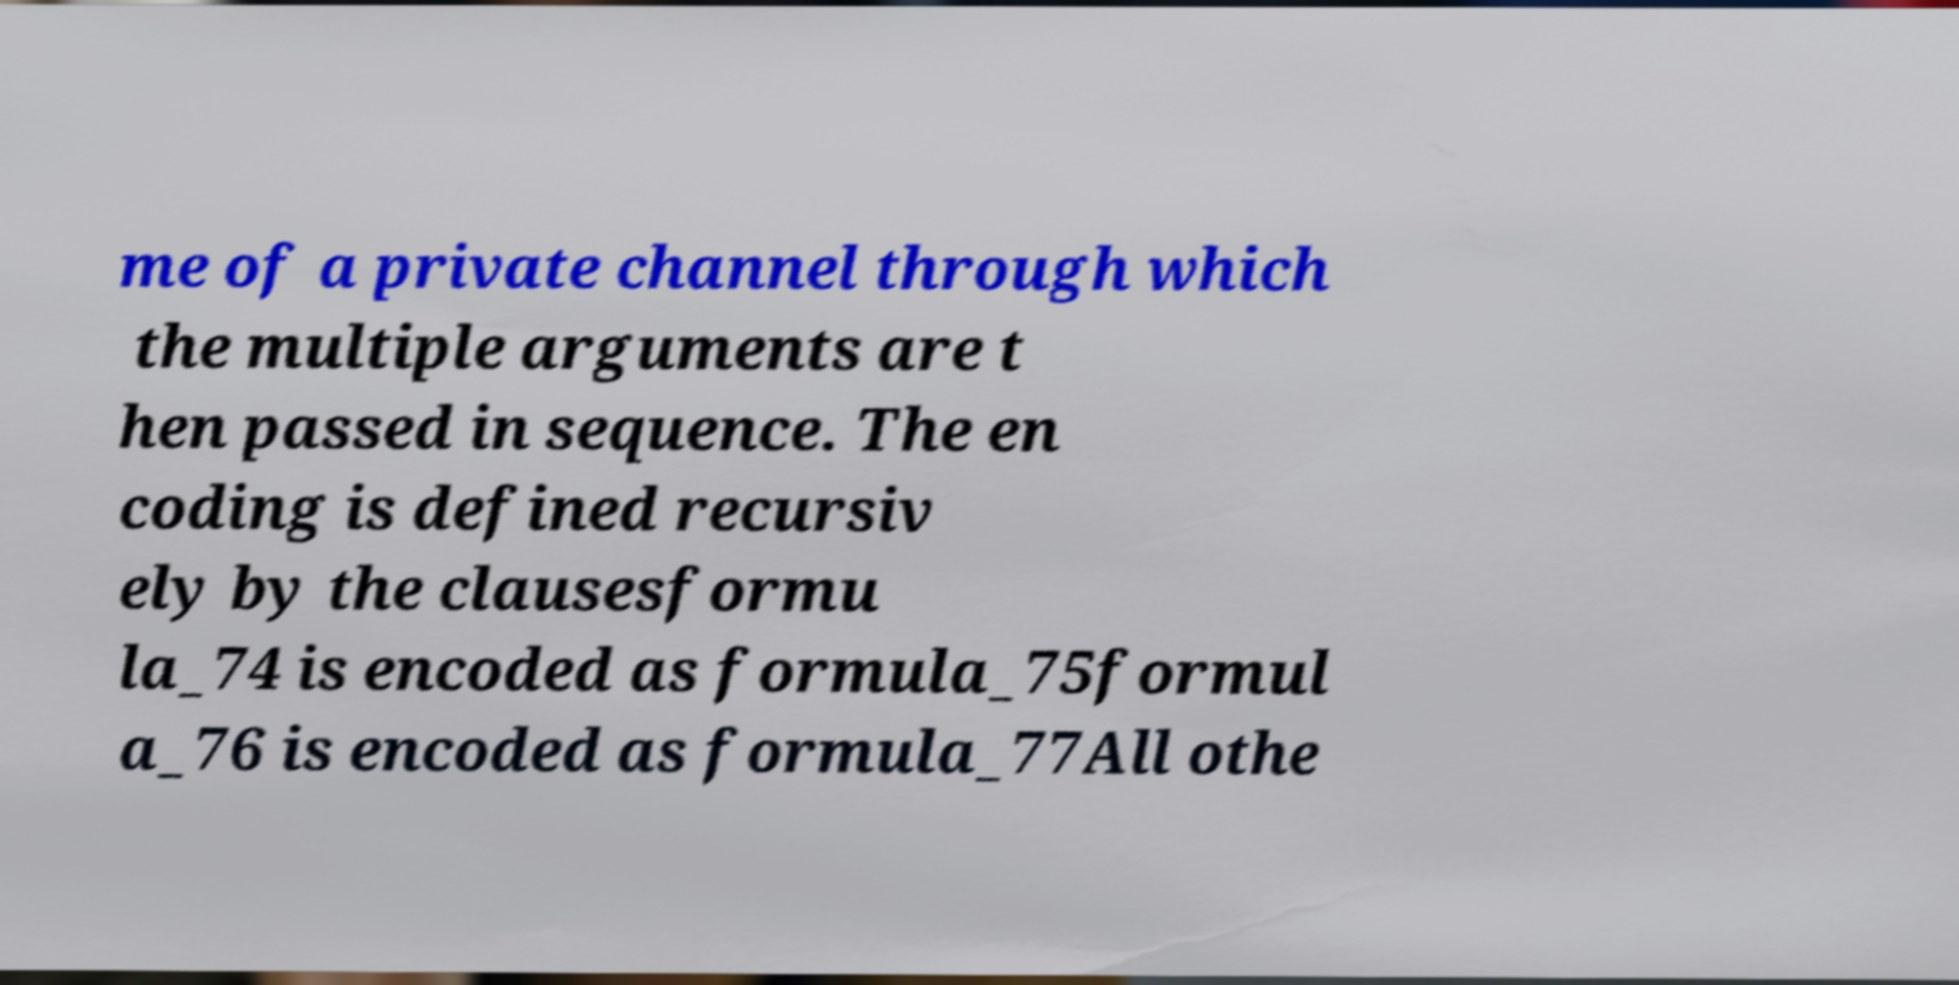Could you extract and type out the text from this image? me of a private channel through which the multiple arguments are t hen passed in sequence. The en coding is defined recursiv ely by the clausesformu la_74 is encoded as formula_75formul a_76 is encoded as formula_77All othe 